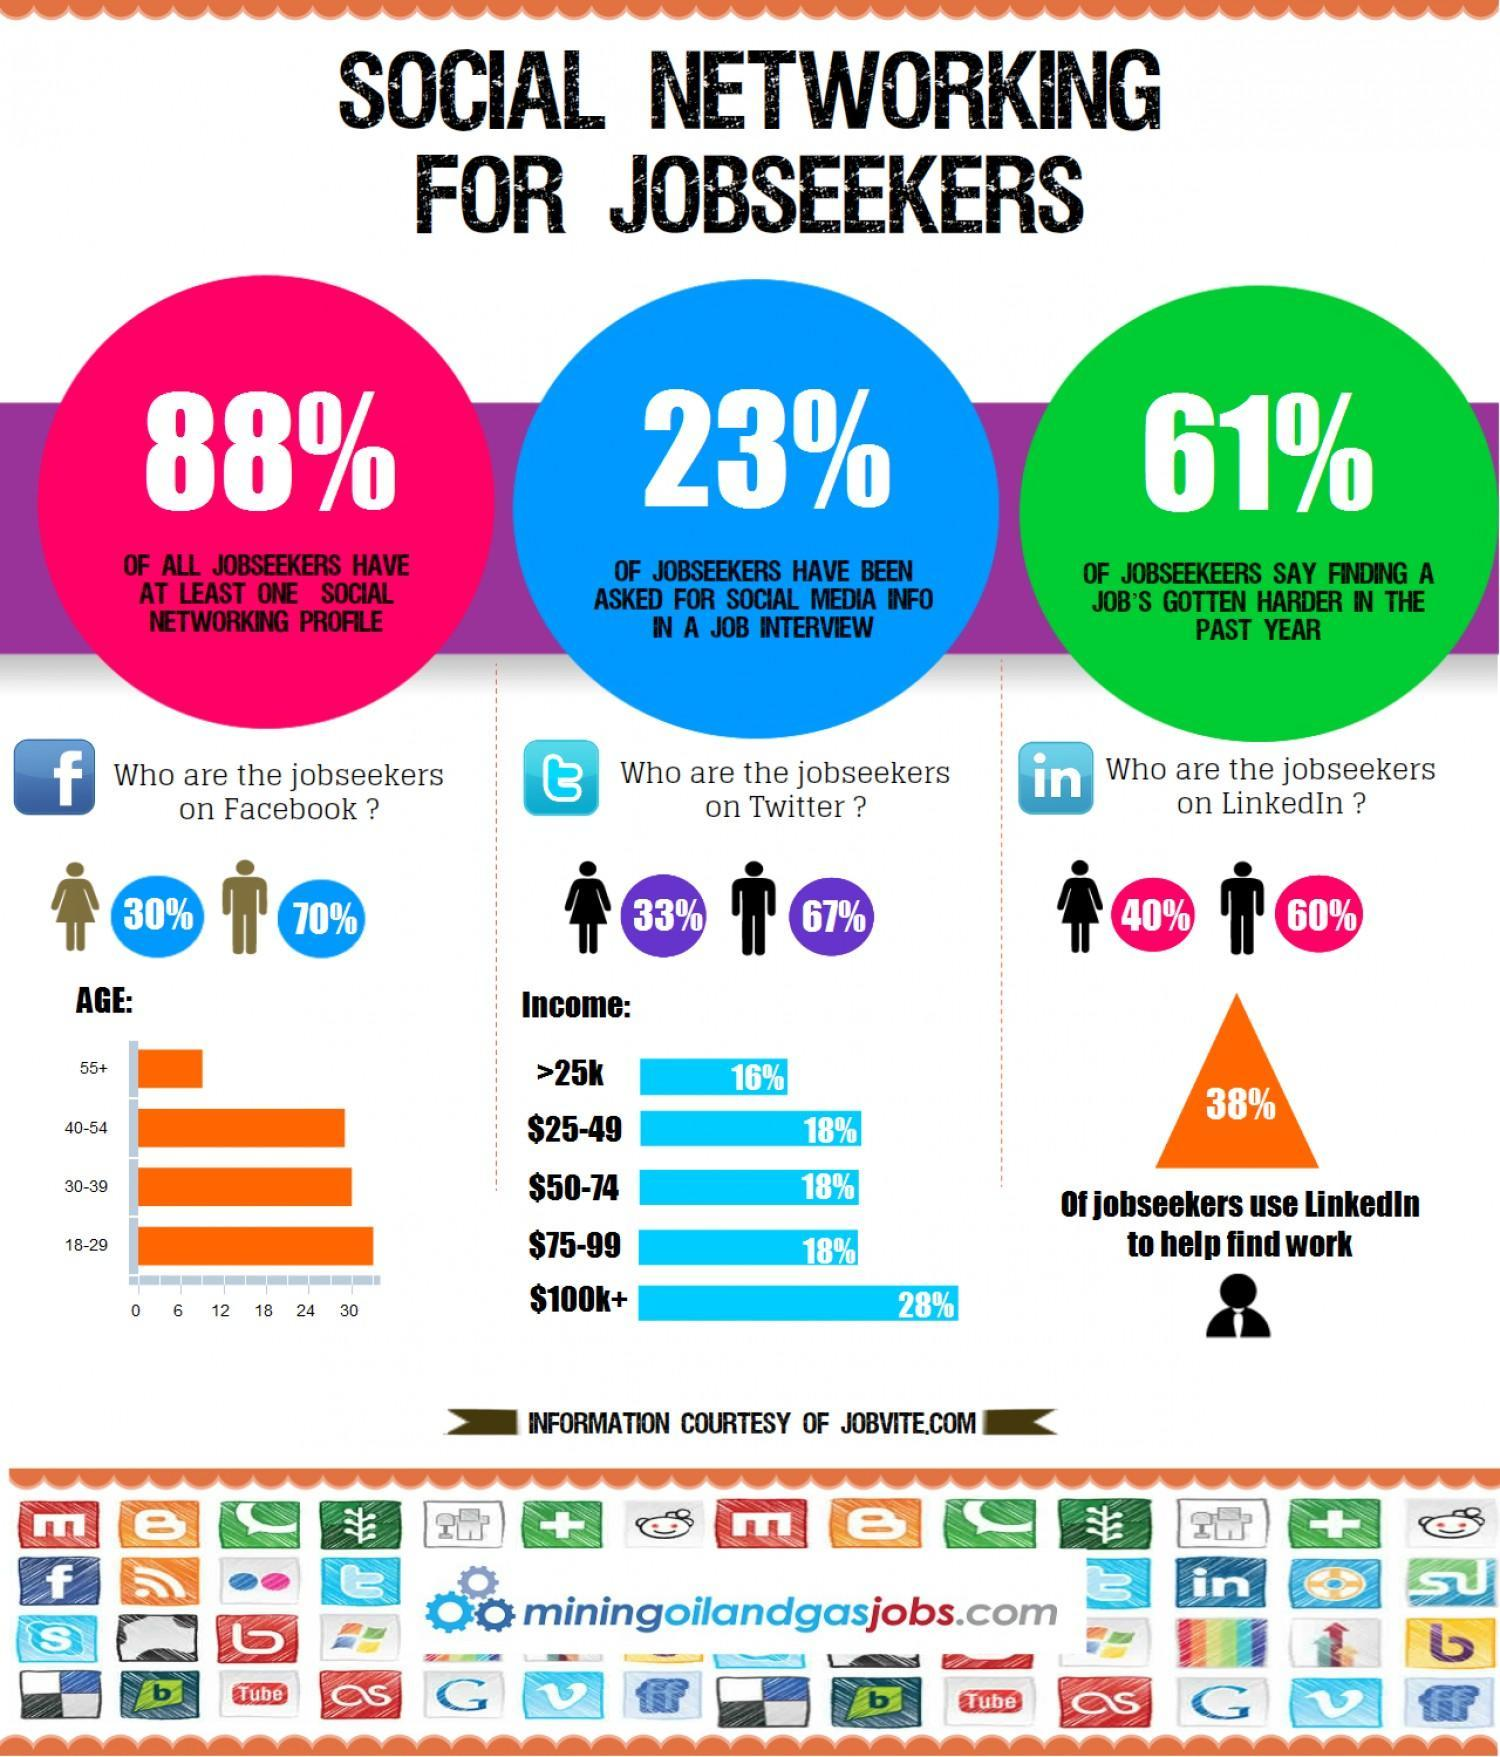What percent of jobseekers do not have a social networking profile?
Answer the question with a short phrase. 12% What percent of jobseekers do not use LinkedIn to find work? 62% Which age groups use Facebook the most for jobseeking? 18-29 What percent have incomes in the range $25-74k? 36% What percent of females are jobseekers on Facebook? 30% Are males or females more in number when jobseeking on Twitter? males 